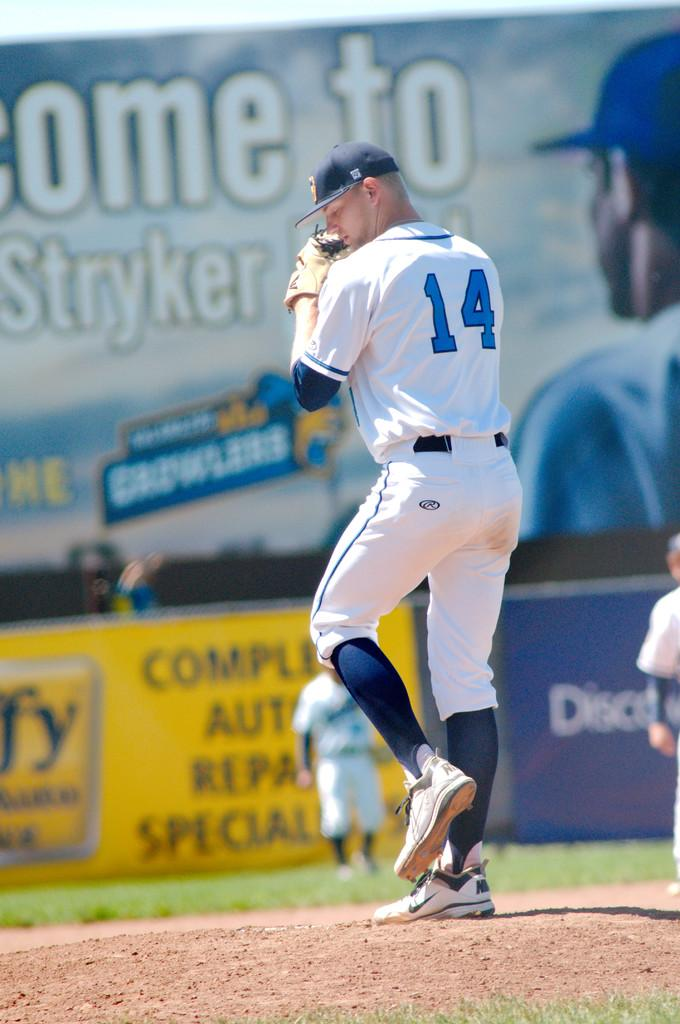<image>
Relay a brief, clear account of the picture shown. A person wearing a number 14 jersey gets ready to pitch a baseball. 